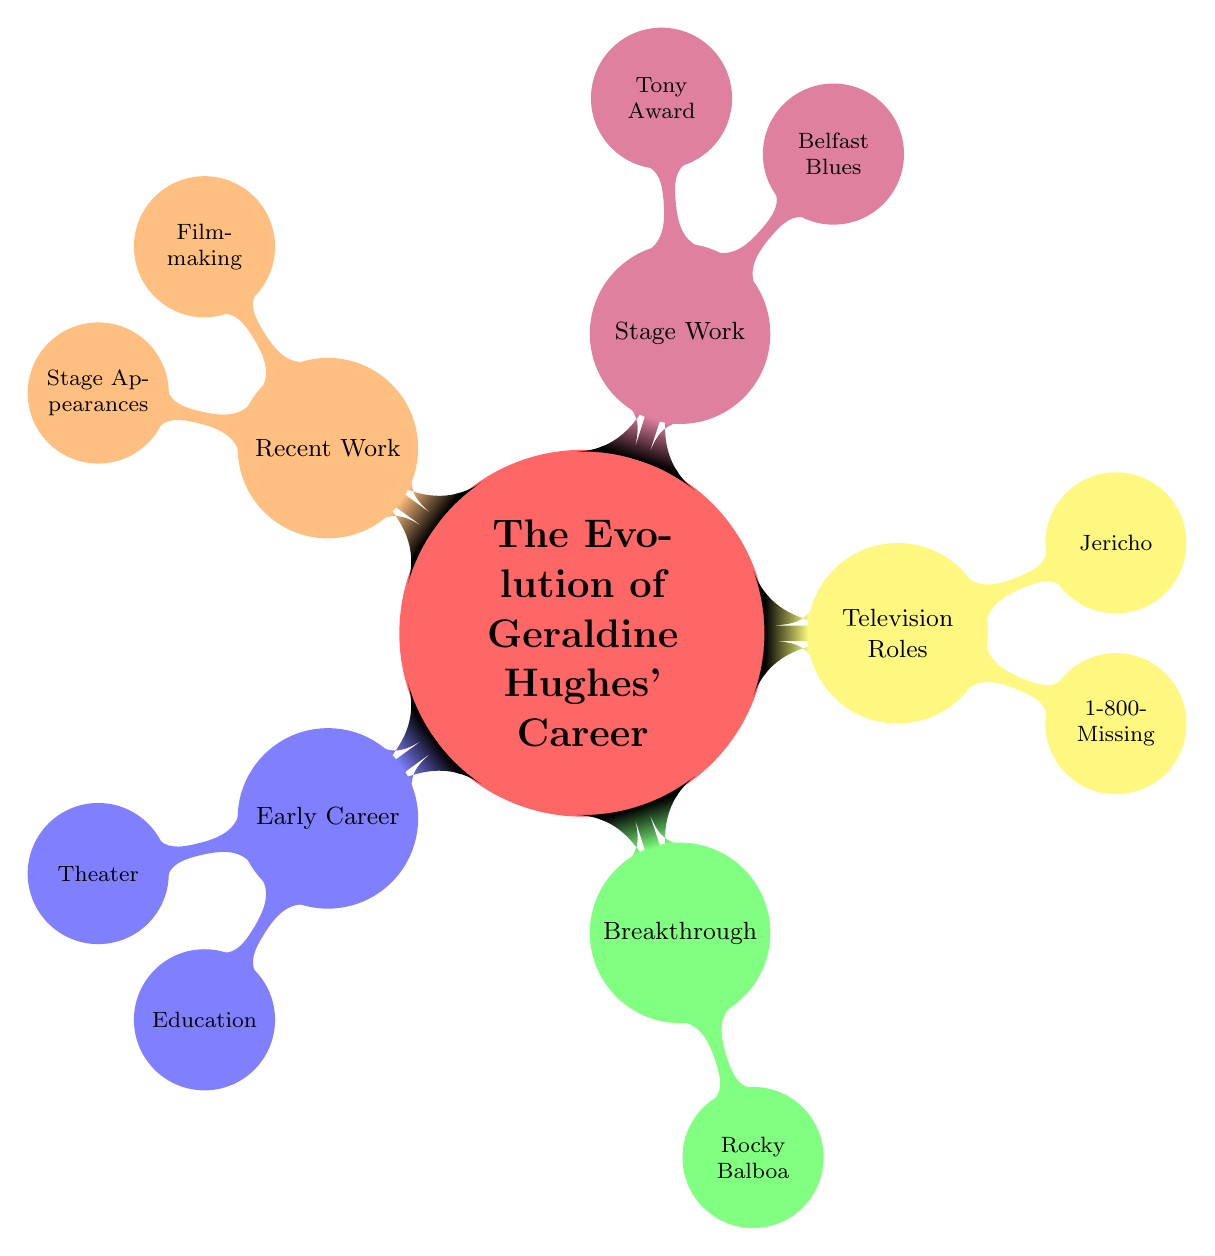What is the first subtopic in the diagram? The first subtopic, according to the arrangement in the diagram, is "Early Career" which is positioned after the main topic.
Answer: Early Career How many subtopics are there in total? The diagram has five subtopics branching from the main topic, which are "Early Career," "Breakthrough," "Television Roles," "Stage Work," and "Recent Work."
Answer: 5 Which film marked Geraldine Hughes' breakthrough role? The node under the "Breakthrough" subtopic indicates that "Rocky Balboa" is the film that marked her breakthrough role.
Answer: Rocky Balboa Where did Geraldine Hughes study? The "Education" node under the "Early Career" subtopic provides the information that she studied at the London Academy of Music and Dramatic Art.
Answer: London Academy of Music and Dramatic Art What type of work is "Belfast Blues"? The "Belfast Blues" is mentioned in the "Stage Work" subtopic as a one-woman show, indicating its theatrical nature.
Answer: One-Woman Show What role did Geraldine Hughes play in "1-800-Missing"? The "1-800-Missing" node under the "Television Roles" subtopic describes her role as Agent Janey Cooper.
Answer: Agent Janey Cooper Which recent work was she involved in as a director? The "Filmmaking" node under "Recent Work" states that she directed a short film titled "Ravenous," indicating her directorial involvement.
Answer: Ravenous How many television roles are listed in the diagram? The "Television Roles" subtopic contains two notable roles: "1-800-Missing" and "Jericho," hence the count of the roles is two.
Answer: 2 Which award did Geraldine Hughes receive a nomination for? The "Tony Award" node under the "Stage Work" subtopic indicates that she received a nomination for her performance in "Jerusalem" on Broadway.
Answer: Tony Award 